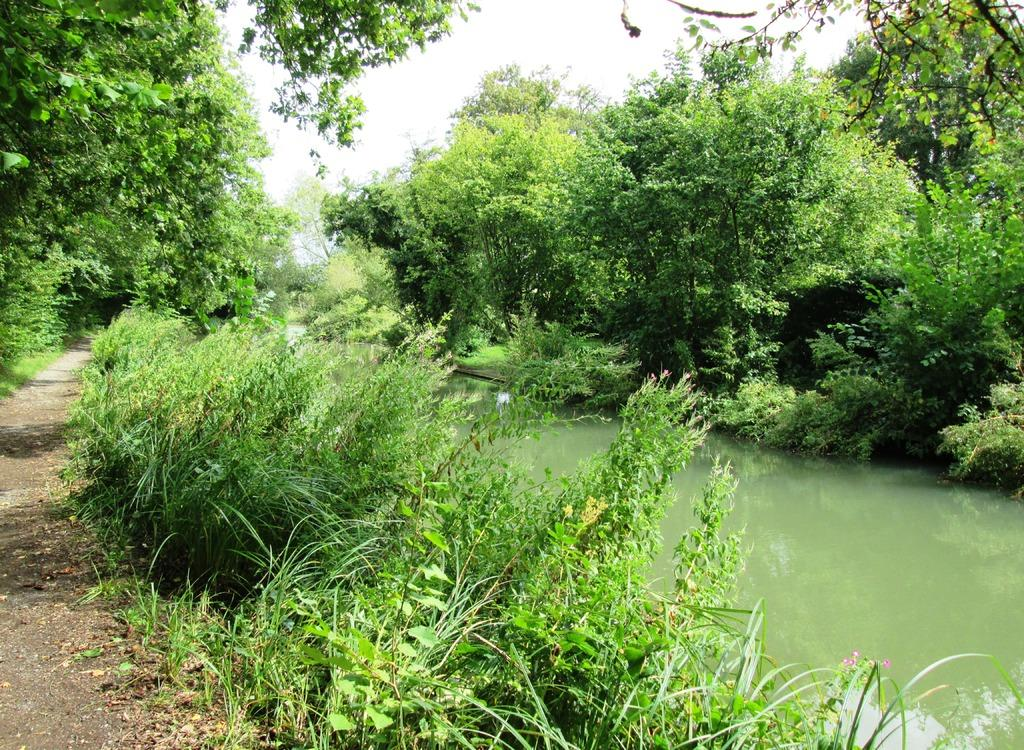What is the primary element visible in the image? There is water in the image. What other natural elements can be seen in the image? There are plants in the image. What can be seen in the background of the image? There are trees and the sky visible in the background of the image. How many bikes are visible in the image? There are no bikes present in the image. How long does it take for the water to blow away in the image? The image does not depict any blowing wind or movement of the water, so it is not possible to determine how long it would take for the water to blow away. 